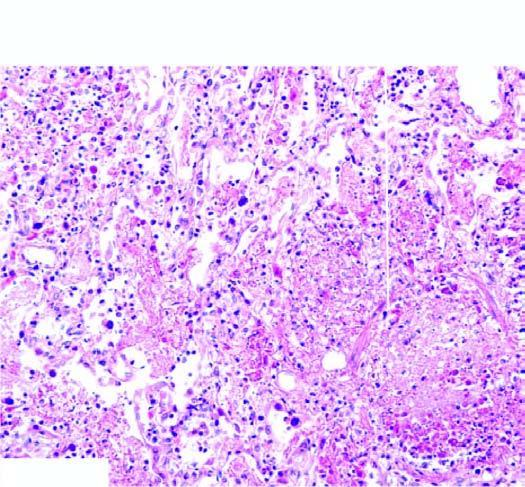what is there in the figure?
Answer the question using a single word or phrase. Microscopic appearance of interstitial pneumonitis 